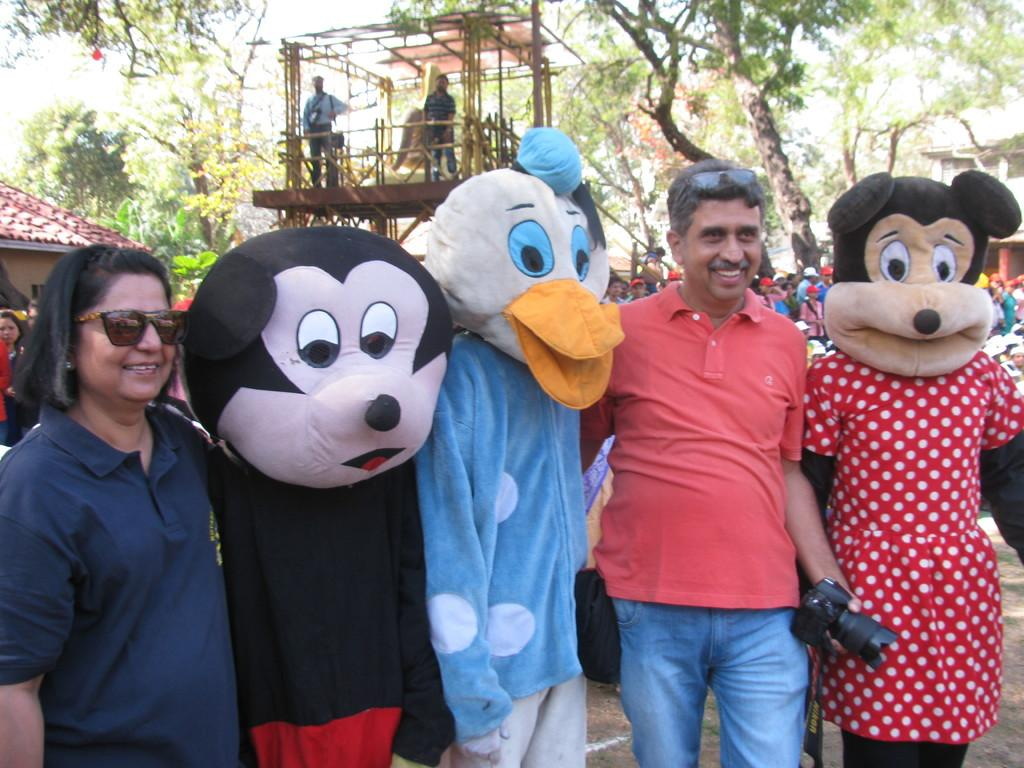What type of structures can be seen in the image? There are buildings in the image. Are there any people present in the image? Yes, there are people standing in the image. What are some people wearing in the image? Some people are wearing masks in the image. What type of vegetation is visible in the image? There are trees in the image. What kind of platform is present in the image? There is a wooden stage in the image. What flavor of cake is being served on the wooden stage in the image? There is no cake present in the image; it features a wooden stage with people standing on it. What type of curtain can be seen hanging from the buildings in the image? There are no curtains visible in the image; only buildings, people, trees, and a wooden stage are present. 